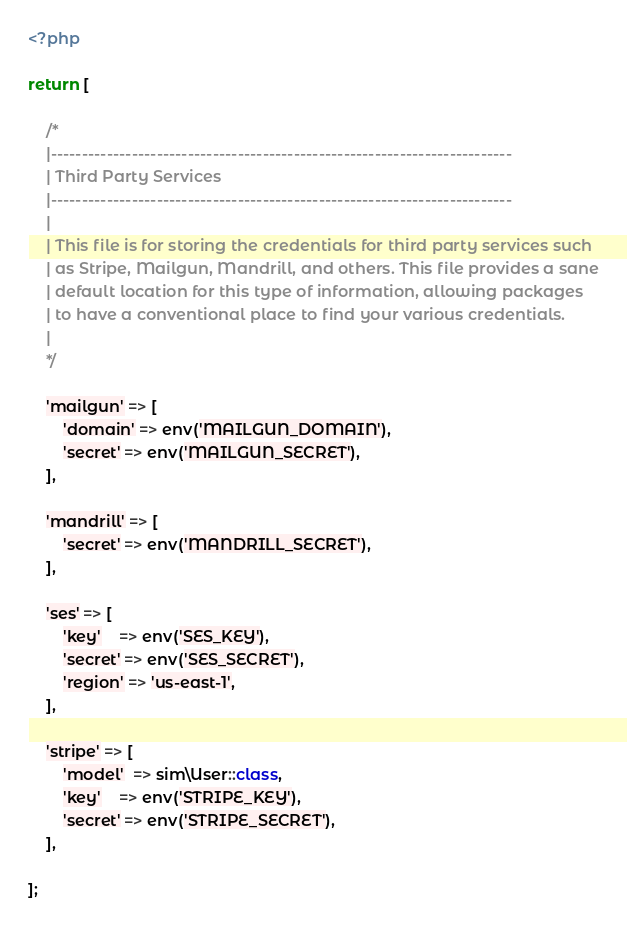<code> <loc_0><loc_0><loc_500><loc_500><_PHP_><?php

return [

    /*
    |--------------------------------------------------------------------------
    | Third Party Services
    |--------------------------------------------------------------------------
    |
    | This file is for storing the credentials for third party services such
    | as Stripe, Mailgun, Mandrill, and others. This file provides a sane
    | default location for this type of information, allowing packages
    | to have a conventional place to find your various credentials.
    |
    */

    'mailgun' => [
        'domain' => env('MAILGUN_DOMAIN'),
        'secret' => env('MAILGUN_SECRET'),
    ],

    'mandrill' => [
        'secret' => env('MANDRILL_SECRET'),
    ],

    'ses' => [
        'key'    => env('SES_KEY'),
        'secret' => env('SES_SECRET'),
        'region' => 'us-east-1',
    ],

    'stripe' => [
        'model'  => sim\User::class,
        'key'    => env('STRIPE_KEY'),
        'secret' => env('STRIPE_SECRET'),
    ],

];
</code> 